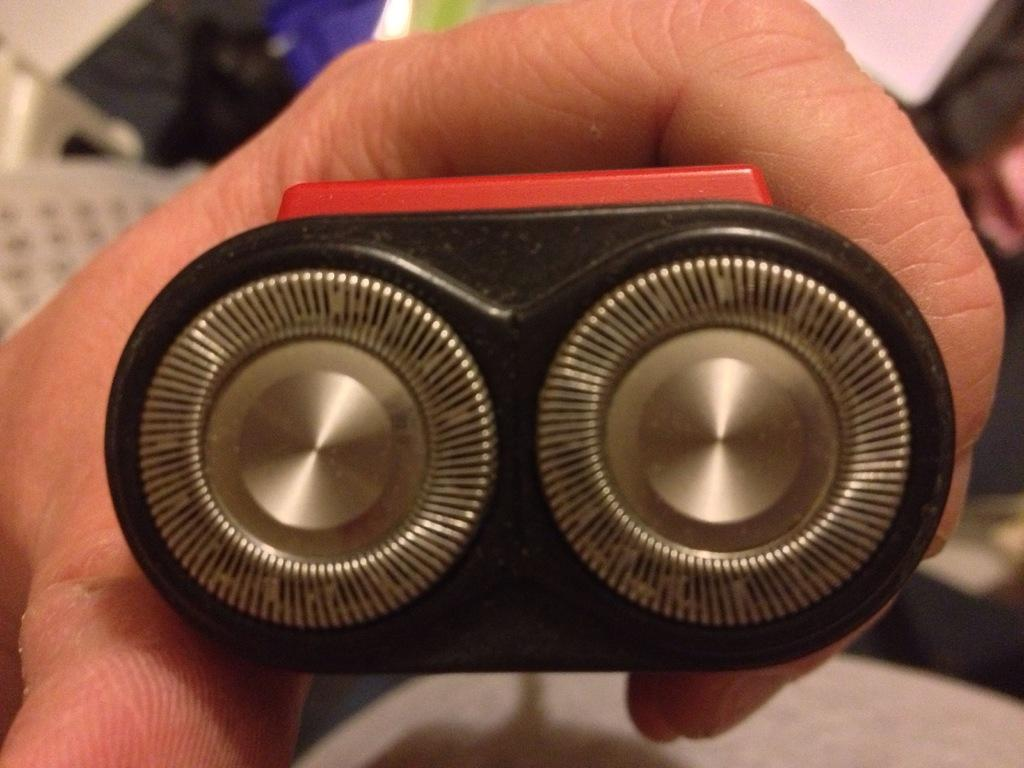What can be seen in the image related to a person? There is a hand of a person in the image. What is the hand holding in the image? The hand is holding an object. Can you tell me how deep the lake is in the image? There is no lake present in the image. What decision is the person making in the image? The image does not provide any information about a decision being made by the person. 